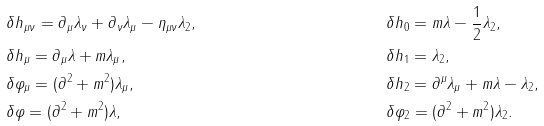Convert formula to latex. <formula><loc_0><loc_0><loc_500><loc_500>& \delta h _ { \mu \nu } = \partial _ { \mu } \lambda _ { \nu } + \partial _ { \nu } \lambda _ { \mu } - \eta _ { \mu \nu } \lambda _ { 2 } , & & \delta h _ { 0 } = m \lambda - \frac { 1 } { 2 } \lambda _ { 2 } , \\ & \delta h _ { \mu } = \partial _ { \mu } \lambda + m \lambda _ { \mu } , & & \delta h _ { 1 } = \lambda _ { 2 } , \\ & \delta \varphi _ { \mu } = ( \partial ^ { 2 } + m ^ { 2 } ) \lambda _ { \mu } , & & \delta h _ { 2 } = \partial ^ { \mu } \lambda _ { \mu } + m \lambda - \lambda _ { 2 } , \\ & \delta \varphi = ( \partial ^ { 2 } + m ^ { 2 } ) \lambda , & & \delta \varphi _ { 2 } = ( \partial ^ { 2 } + m ^ { 2 } ) \lambda _ { 2 } .</formula> 